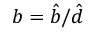Convert formula to latex. <formula><loc_0><loc_0><loc_500><loc_500>b = \hat { b } / \hat { d }</formula> 